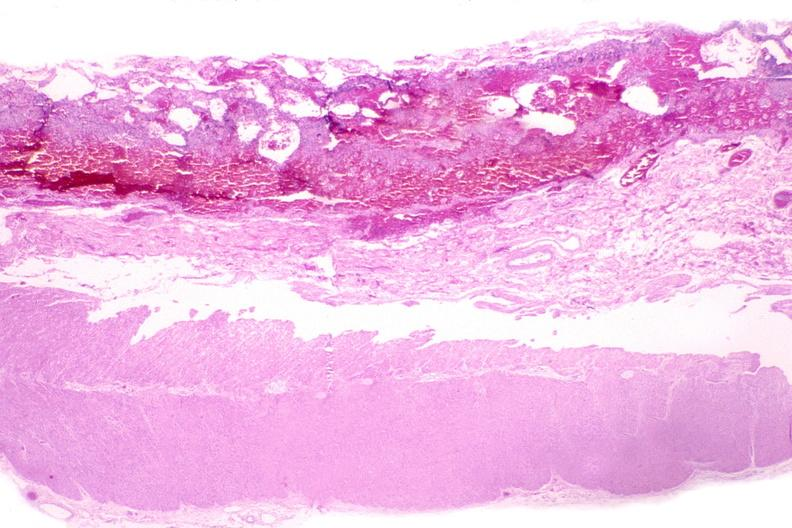does this image show esohagus, candida?
Answer the question using a single word or phrase. Yes 